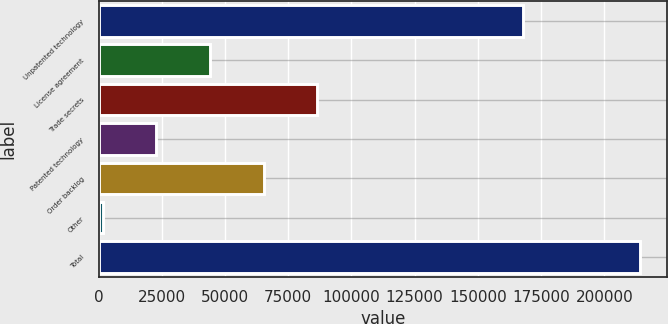Convert chart to OTSL. <chart><loc_0><loc_0><loc_500><loc_500><bar_chart><fcel>Unpatented technology<fcel>License agreement<fcel>Trade secrets<fcel>Patented technology<fcel>Order backlog<fcel>Other<fcel>Total<nl><fcel>168003<fcel>44083.8<fcel>86567.6<fcel>22841.9<fcel>65325.7<fcel>1600<fcel>214019<nl></chart> 